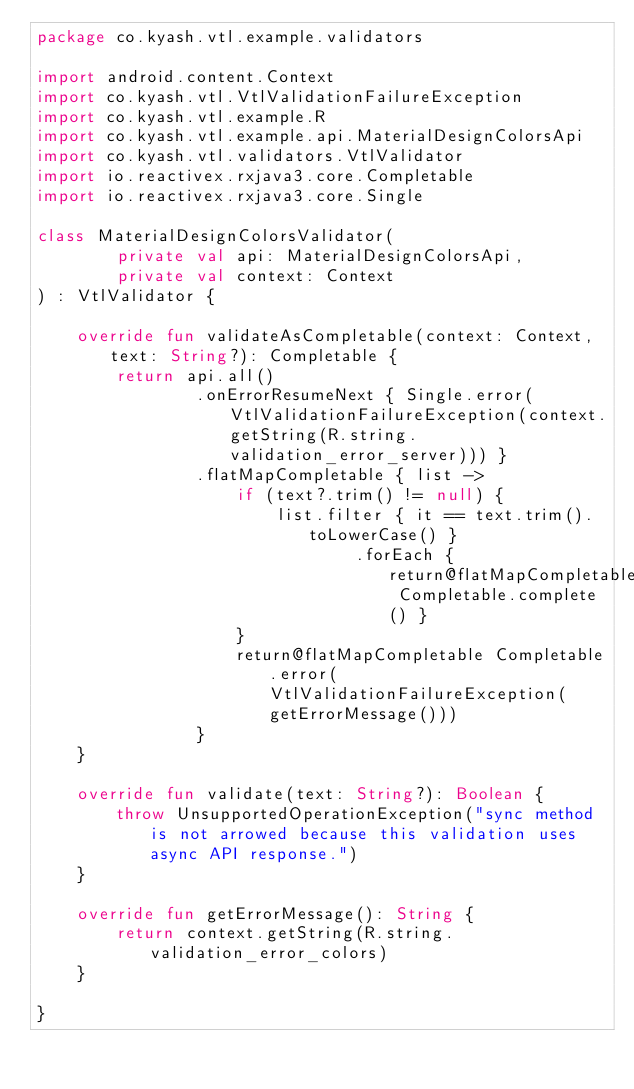<code> <loc_0><loc_0><loc_500><loc_500><_Kotlin_>package co.kyash.vtl.example.validators

import android.content.Context
import co.kyash.vtl.VtlValidationFailureException
import co.kyash.vtl.example.R
import co.kyash.vtl.example.api.MaterialDesignColorsApi
import co.kyash.vtl.validators.VtlValidator
import io.reactivex.rxjava3.core.Completable
import io.reactivex.rxjava3.core.Single

class MaterialDesignColorsValidator(
        private val api: MaterialDesignColorsApi,
        private val context: Context
) : VtlValidator {

    override fun validateAsCompletable(context: Context, text: String?): Completable {
        return api.all()
                .onErrorResumeNext { Single.error(VtlValidationFailureException(context.getString(R.string.validation_error_server))) }
                .flatMapCompletable { list ->
                    if (text?.trim() != null) {
                        list.filter { it == text.trim().toLowerCase() }
                                .forEach { return@flatMapCompletable Completable.complete() }
                    }
                    return@flatMapCompletable Completable.error(VtlValidationFailureException(getErrorMessage()))
                }
    }

    override fun validate(text: String?): Boolean {
        throw UnsupportedOperationException("sync method is not arrowed because this validation uses async API response.")
    }

    override fun getErrorMessage(): String {
        return context.getString(R.string.validation_error_colors)
    }

}
</code> 